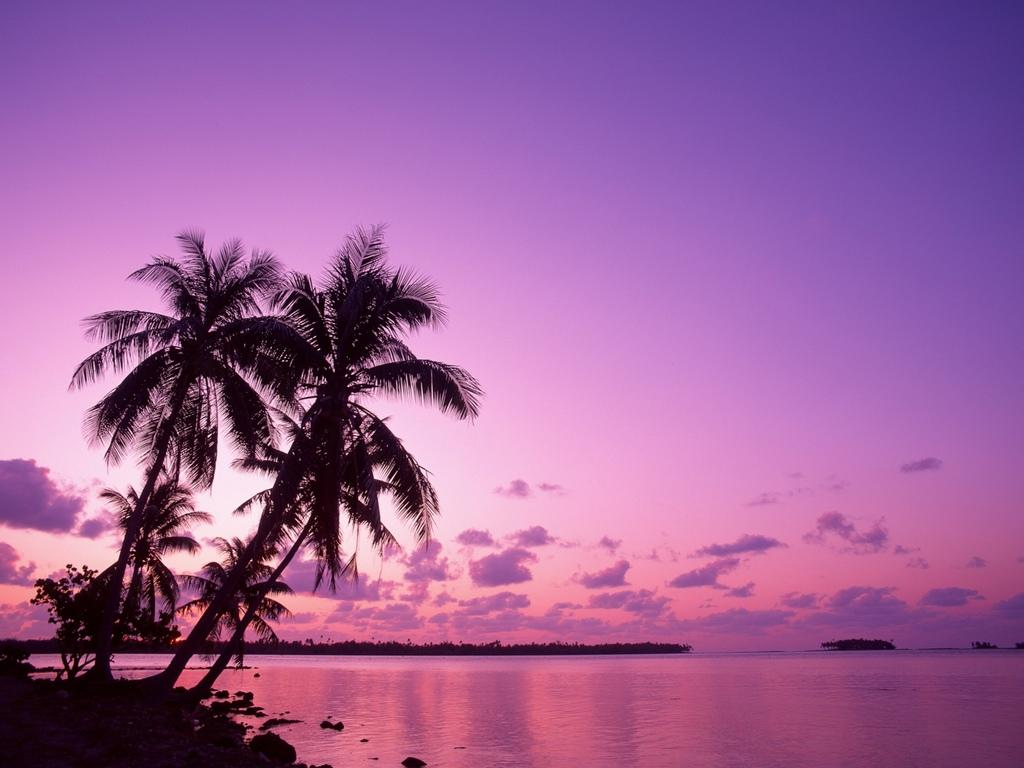What type of natural landscape is depicted in the image? The image features a river with trees in front of it. Can you describe the trees in the image? There are trees visible both in front of the river and in the background of the image. What is visible in the sky at the top of the image? There are clouds in the sky at the top of the image. How does the river gain knowledge in the image? The river does not gain knowledge in the image; it is a natural landscape feature. 